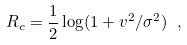<formula> <loc_0><loc_0><loc_500><loc_500>R _ { c } = \frac { 1 } { 2 } \log ( 1 + v ^ { 2 } / \sigma ^ { 2 } ) \ ,</formula> 